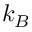<formula> <loc_0><loc_0><loc_500><loc_500>k _ { B }</formula> 